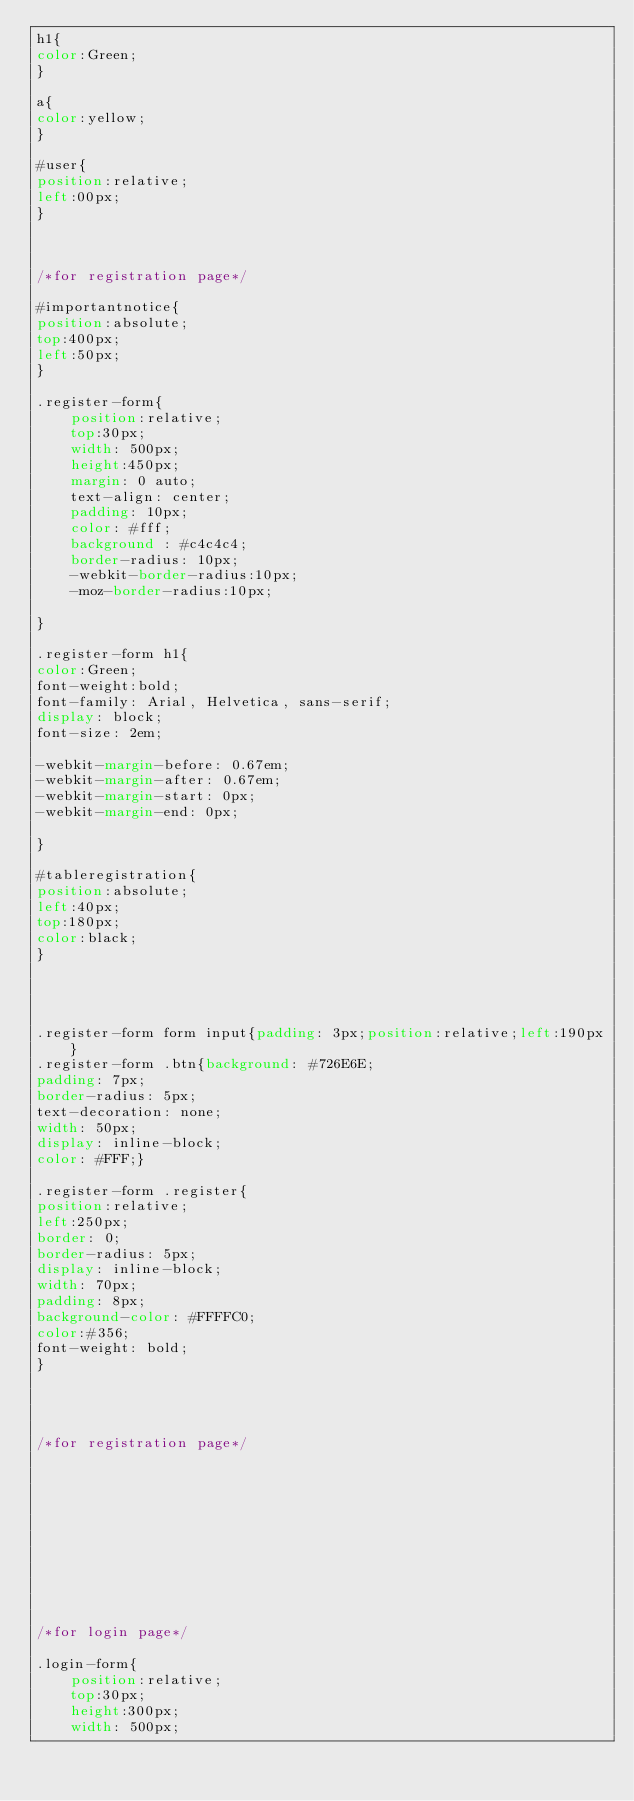Convert code to text. <code><loc_0><loc_0><loc_500><loc_500><_CSS_>h1{
color:Green;
}

a{
color:yellow;
}

#user{
position:relative;
left:00px;
}



/*for registration page*/

#importantnotice{
position:absolute;
top:400px;
left:50px;
}

.register-form{
	position:relative;
	top:30px;
	width: 500px;
	height:450px;
	margin: 0 auto;
	text-align: center;
	padding: 10px;
	color: #fff;
	background : #c4c4c4;
	border-radius: 10px;
	-webkit-border-radius:10px;
	-moz-border-radius:10px;
	
}

.register-form h1{
color:Green;
font-weight:bold;
font-family: Arial, Helvetica, sans-serif;
display: block;
font-size: 2em;

-webkit-margin-before: 0.67em;
-webkit-margin-after: 0.67em;
-webkit-margin-start: 0px;
-webkit-margin-end: 0px;

}

#tableregistration{
position:absolute;
left:40px;
top:180px;
color:black;
}




.register-form form input{padding: 3px;position:relative;left:190px}
.register-form .btn{background: #726E6E;
padding: 7px;
border-radius: 5px;
text-decoration: none;
width: 50px;
display: inline-block;
color: #FFF;}

.register-form .register{
position:relative;
left:250px;
border: 0;
border-radius: 5px;
display: inline-block;
width: 70px;
padding: 8px;
background-color: #FFFFC0;
color:#356;
font-weight: bold;
}




/*for registration page*/











/*for login page*/

.login-form{
	position:relative;
	top:30px;
	height:300px;
	width: 500px;</code> 